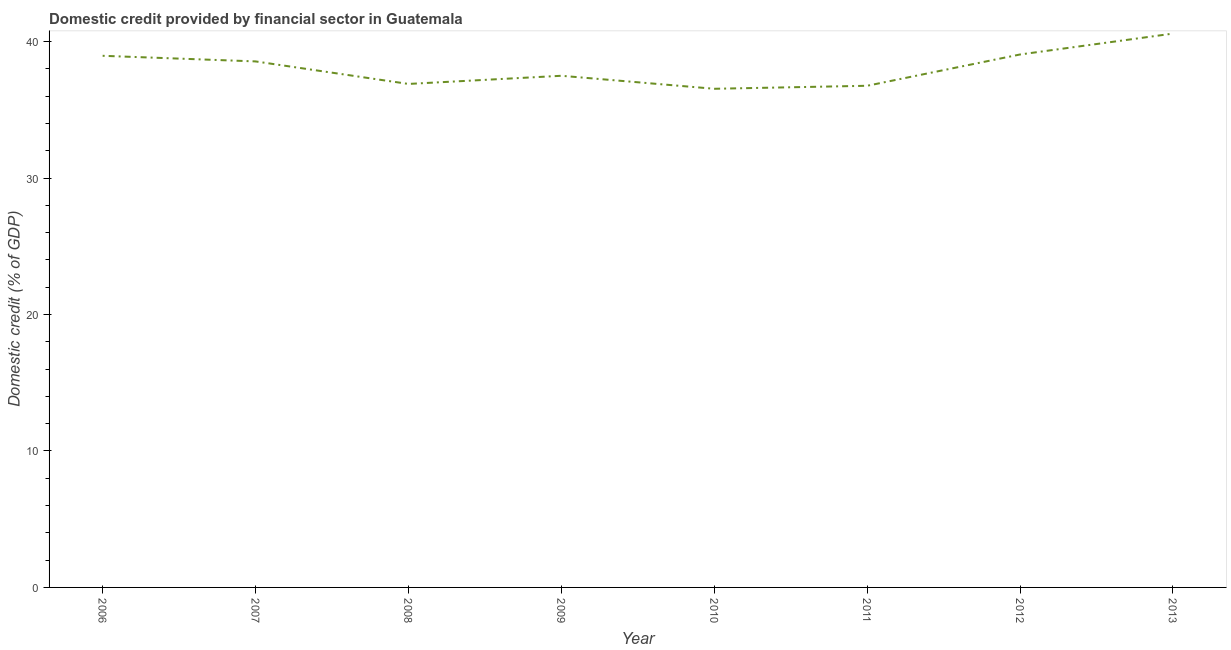What is the domestic credit provided by financial sector in 2009?
Keep it short and to the point. 37.5. Across all years, what is the maximum domestic credit provided by financial sector?
Your response must be concise. 40.59. Across all years, what is the minimum domestic credit provided by financial sector?
Your response must be concise. 36.55. In which year was the domestic credit provided by financial sector maximum?
Make the answer very short. 2013. What is the sum of the domestic credit provided by financial sector?
Provide a short and direct response. 304.88. What is the difference between the domestic credit provided by financial sector in 2007 and 2012?
Offer a terse response. -0.51. What is the average domestic credit provided by financial sector per year?
Your answer should be very brief. 38.11. What is the median domestic credit provided by financial sector?
Provide a short and direct response. 38.03. Do a majority of the years between 2012 and 2008 (inclusive) have domestic credit provided by financial sector greater than 24 %?
Offer a terse response. Yes. What is the ratio of the domestic credit provided by financial sector in 2006 to that in 2008?
Keep it short and to the point. 1.06. Is the domestic credit provided by financial sector in 2008 less than that in 2013?
Keep it short and to the point. Yes. Is the difference between the domestic credit provided by financial sector in 2006 and 2012 greater than the difference between any two years?
Offer a terse response. No. What is the difference between the highest and the second highest domestic credit provided by financial sector?
Offer a terse response. 1.53. Is the sum of the domestic credit provided by financial sector in 2006 and 2011 greater than the maximum domestic credit provided by financial sector across all years?
Your response must be concise. Yes. What is the difference between the highest and the lowest domestic credit provided by financial sector?
Provide a succinct answer. 4.04. Does the domestic credit provided by financial sector monotonically increase over the years?
Ensure brevity in your answer.  No. What is the difference between two consecutive major ticks on the Y-axis?
Provide a short and direct response. 10. Are the values on the major ticks of Y-axis written in scientific E-notation?
Your answer should be compact. No. What is the title of the graph?
Your response must be concise. Domestic credit provided by financial sector in Guatemala. What is the label or title of the X-axis?
Ensure brevity in your answer.  Year. What is the label or title of the Y-axis?
Offer a terse response. Domestic credit (% of GDP). What is the Domestic credit (% of GDP) in 2006?
Your response must be concise. 38.96. What is the Domestic credit (% of GDP) in 2007?
Ensure brevity in your answer.  38.55. What is the Domestic credit (% of GDP) of 2008?
Provide a short and direct response. 36.9. What is the Domestic credit (% of GDP) of 2009?
Offer a very short reply. 37.5. What is the Domestic credit (% of GDP) of 2010?
Your answer should be compact. 36.55. What is the Domestic credit (% of GDP) in 2011?
Give a very brief answer. 36.77. What is the Domestic credit (% of GDP) of 2012?
Provide a succinct answer. 39.06. What is the Domestic credit (% of GDP) of 2013?
Make the answer very short. 40.59. What is the difference between the Domestic credit (% of GDP) in 2006 and 2007?
Provide a short and direct response. 0.41. What is the difference between the Domestic credit (% of GDP) in 2006 and 2008?
Make the answer very short. 2.06. What is the difference between the Domestic credit (% of GDP) in 2006 and 2009?
Make the answer very short. 1.46. What is the difference between the Domestic credit (% of GDP) in 2006 and 2010?
Offer a very short reply. 2.42. What is the difference between the Domestic credit (% of GDP) in 2006 and 2011?
Ensure brevity in your answer.  2.2. What is the difference between the Domestic credit (% of GDP) in 2006 and 2012?
Give a very brief answer. -0.1. What is the difference between the Domestic credit (% of GDP) in 2006 and 2013?
Offer a terse response. -1.63. What is the difference between the Domestic credit (% of GDP) in 2007 and 2008?
Offer a terse response. 1.65. What is the difference between the Domestic credit (% of GDP) in 2007 and 2009?
Offer a terse response. 1.05. What is the difference between the Domestic credit (% of GDP) in 2007 and 2010?
Offer a terse response. 2.01. What is the difference between the Domestic credit (% of GDP) in 2007 and 2011?
Your answer should be compact. 1.79. What is the difference between the Domestic credit (% of GDP) in 2007 and 2012?
Your answer should be compact. -0.51. What is the difference between the Domestic credit (% of GDP) in 2007 and 2013?
Give a very brief answer. -2.04. What is the difference between the Domestic credit (% of GDP) in 2008 and 2009?
Keep it short and to the point. -0.6. What is the difference between the Domestic credit (% of GDP) in 2008 and 2010?
Ensure brevity in your answer.  0.35. What is the difference between the Domestic credit (% of GDP) in 2008 and 2011?
Keep it short and to the point. 0.13. What is the difference between the Domestic credit (% of GDP) in 2008 and 2012?
Make the answer very short. -2.16. What is the difference between the Domestic credit (% of GDP) in 2008 and 2013?
Your response must be concise. -3.69. What is the difference between the Domestic credit (% of GDP) in 2009 and 2010?
Provide a short and direct response. 0.95. What is the difference between the Domestic credit (% of GDP) in 2009 and 2011?
Your answer should be very brief. 0.73. What is the difference between the Domestic credit (% of GDP) in 2009 and 2012?
Your answer should be compact. -1.56. What is the difference between the Domestic credit (% of GDP) in 2009 and 2013?
Keep it short and to the point. -3.09. What is the difference between the Domestic credit (% of GDP) in 2010 and 2011?
Provide a short and direct response. -0.22. What is the difference between the Domestic credit (% of GDP) in 2010 and 2012?
Your answer should be very brief. -2.51. What is the difference between the Domestic credit (% of GDP) in 2010 and 2013?
Offer a very short reply. -4.04. What is the difference between the Domestic credit (% of GDP) in 2011 and 2012?
Ensure brevity in your answer.  -2.29. What is the difference between the Domestic credit (% of GDP) in 2011 and 2013?
Your answer should be very brief. -3.82. What is the difference between the Domestic credit (% of GDP) in 2012 and 2013?
Make the answer very short. -1.53. What is the ratio of the Domestic credit (% of GDP) in 2006 to that in 2008?
Keep it short and to the point. 1.06. What is the ratio of the Domestic credit (% of GDP) in 2006 to that in 2009?
Make the answer very short. 1.04. What is the ratio of the Domestic credit (% of GDP) in 2006 to that in 2010?
Provide a succinct answer. 1.07. What is the ratio of the Domestic credit (% of GDP) in 2006 to that in 2011?
Provide a succinct answer. 1.06. What is the ratio of the Domestic credit (% of GDP) in 2006 to that in 2012?
Your answer should be compact. 1. What is the ratio of the Domestic credit (% of GDP) in 2007 to that in 2008?
Keep it short and to the point. 1.04. What is the ratio of the Domestic credit (% of GDP) in 2007 to that in 2009?
Offer a very short reply. 1.03. What is the ratio of the Domestic credit (% of GDP) in 2007 to that in 2010?
Provide a succinct answer. 1.05. What is the ratio of the Domestic credit (% of GDP) in 2007 to that in 2011?
Your answer should be compact. 1.05. What is the ratio of the Domestic credit (% of GDP) in 2007 to that in 2013?
Provide a short and direct response. 0.95. What is the ratio of the Domestic credit (% of GDP) in 2008 to that in 2011?
Ensure brevity in your answer.  1. What is the ratio of the Domestic credit (% of GDP) in 2008 to that in 2012?
Provide a succinct answer. 0.94. What is the ratio of the Domestic credit (% of GDP) in 2008 to that in 2013?
Make the answer very short. 0.91. What is the ratio of the Domestic credit (% of GDP) in 2009 to that in 2010?
Your answer should be very brief. 1.03. What is the ratio of the Domestic credit (% of GDP) in 2009 to that in 2011?
Make the answer very short. 1.02. What is the ratio of the Domestic credit (% of GDP) in 2009 to that in 2012?
Keep it short and to the point. 0.96. What is the ratio of the Domestic credit (% of GDP) in 2009 to that in 2013?
Provide a short and direct response. 0.92. What is the ratio of the Domestic credit (% of GDP) in 2010 to that in 2011?
Your response must be concise. 0.99. What is the ratio of the Domestic credit (% of GDP) in 2010 to that in 2012?
Ensure brevity in your answer.  0.94. What is the ratio of the Domestic credit (% of GDP) in 2011 to that in 2012?
Provide a short and direct response. 0.94. What is the ratio of the Domestic credit (% of GDP) in 2011 to that in 2013?
Offer a very short reply. 0.91. What is the ratio of the Domestic credit (% of GDP) in 2012 to that in 2013?
Ensure brevity in your answer.  0.96. 